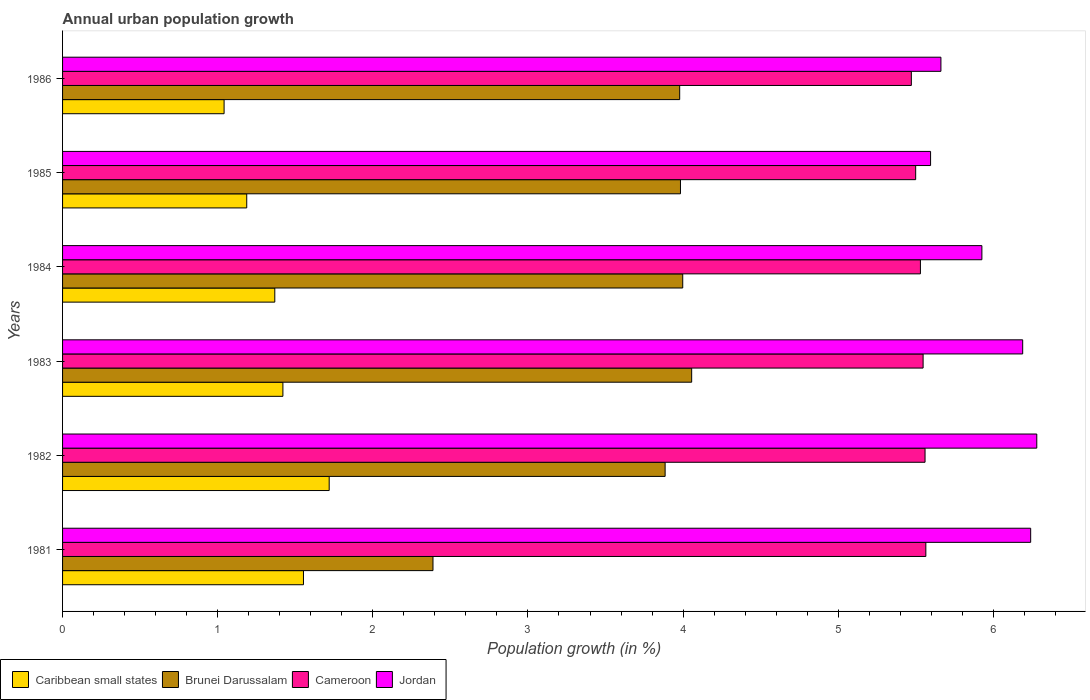How many different coloured bars are there?
Your answer should be very brief. 4. Are the number of bars per tick equal to the number of legend labels?
Your answer should be very brief. Yes. How many bars are there on the 1st tick from the top?
Your answer should be compact. 4. What is the label of the 4th group of bars from the top?
Make the answer very short. 1983. In how many cases, is the number of bars for a given year not equal to the number of legend labels?
Offer a very short reply. 0. What is the percentage of urban population growth in Jordan in 1983?
Ensure brevity in your answer.  6.19. Across all years, what is the maximum percentage of urban population growth in Jordan?
Make the answer very short. 6.28. Across all years, what is the minimum percentage of urban population growth in Brunei Darussalam?
Your answer should be compact. 2.39. In which year was the percentage of urban population growth in Jordan minimum?
Provide a succinct answer. 1985. What is the total percentage of urban population growth in Cameroon in the graph?
Ensure brevity in your answer.  33.17. What is the difference between the percentage of urban population growth in Jordan in 1983 and that in 1986?
Your answer should be compact. 0.53. What is the difference between the percentage of urban population growth in Cameroon in 1985 and the percentage of urban population growth in Jordan in 1986?
Provide a succinct answer. -0.16. What is the average percentage of urban population growth in Caribbean small states per year?
Offer a terse response. 1.38. In the year 1984, what is the difference between the percentage of urban population growth in Cameroon and percentage of urban population growth in Brunei Darussalam?
Your answer should be very brief. 1.53. What is the ratio of the percentage of urban population growth in Caribbean small states in 1982 to that in 1986?
Offer a very short reply. 1.65. Is the percentage of urban population growth in Cameroon in 1983 less than that in 1986?
Make the answer very short. No. What is the difference between the highest and the second highest percentage of urban population growth in Caribbean small states?
Keep it short and to the point. 0.17. What is the difference between the highest and the lowest percentage of urban population growth in Jordan?
Keep it short and to the point. 0.68. What does the 3rd bar from the top in 1984 represents?
Offer a very short reply. Brunei Darussalam. What does the 3rd bar from the bottom in 1981 represents?
Provide a succinct answer. Cameroon. How many bars are there?
Make the answer very short. 24. Are all the bars in the graph horizontal?
Offer a terse response. Yes. How many years are there in the graph?
Offer a very short reply. 6. What is the difference between two consecutive major ticks on the X-axis?
Keep it short and to the point. 1. Does the graph contain any zero values?
Give a very brief answer. No. What is the title of the graph?
Your answer should be compact. Annual urban population growth. What is the label or title of the X-axis?
Provide a short and direct response. Population growth (in %). What is the Population growth (in %) of Caribbean small states in 1981?
Your response must be concise. 1.55. What is the Population growth (in %) in Brunei Darussalam in 1981?
Your response must be concise. 2.39. What is the Population growth (in %) in Cameroon in 1981?
Provide a succinct answer. 5.56. What is the Population growth (in %) of Jordan in 1981?
Keep it short and to the point. 6.24. What is the Population growth (in %) of Caribbean small states in 1982?
Keep it short and to the point. 1.72. What is the Population growth (in %) of Brunei Darussalam in 1982?
Ensure brevity in your answer.  3.88. What is the Population growth (in %) of Cameroon in 1982?
Give a very brief answer. 5.56. What is the Population growth (in %) in Jordan in 1982?
Your answer should be compact. 6.28. What is the Population growth (in %) of Caribbean small states in 1983?
Ensure brevity in your answer.  1.42. What is the Population growth (in %) in Brunei Darussalam in 1983?
Ensure brevity in your answer.  4.06. What is the Population growth (in %) of Cameroon in 1983?
Make the answer very short. 5.55. What is the Population growth (in %) of Jordan in 1983?
Give a very brief answer. 6.19. What is the Population growth (in %) in Caribbean small states in 1984?
Offer a terse response. 1.37. What is the Population growth (in %) in Brunei Darussalam in 1984?
Ensure brevity in your answer.  4. What is the Population growth (in %) of Cameroon in 1984?
Provide a succinct answer. 5.53. What is the Population growth (in %) in Jordan in 1984?
Give a very brief answer. 5.93. What is the Population growth (in %) in Caribbean small states in 1985?
Offer a terse response. 1.19. What is the Population growth (in %) in Brunei Darussalam in 1985?
Keep it short and to the point. 3.98. What is the Population growth (in %) in Cameroon in 1985?
Offer a very short reply. 5.5. What is the Population growth (in %) in Jordan in 1985?
Offer a very short reply. 5.6. What is the Population growth (in %) in Caribbean small states in 1986?
Keep it short and to the point. 1.04. What is the Population growth (in %) in Brunei Darussalam in 1986?
Keep it short and to the point. 3.98. What is the Population growth (in %) in Cameroon in 1986?
Provide a short and direct response. 5.47. What is the Population growth (in %) of Jordan in 1986?
Provide a succinct answer. 5.66. Across all years, what is the maximum Population growth (in %) in Caribbean small states?
Your answer should be compact. 1.72. Across all years, what is the maximum Population growth (in %) in Brunei Darussalam?
Provide a short and direct response. 4.06. Across all years, what is the maximum Population growth (in %) in Cameroon?
Give a very brief answer. 5.56. Across all years, what is the maximum Population growth (in %) in Jordan?
Your answer should be compact. 6.28. Across all years, what is the minimum Population growth (in %) in Caribbean small states?
Your response must be concise. 1.04. Across all years, what is the minimum Population growth (in %) in Brunei Darussalam?
Make the answer very short. 2.39. Across all years, what is the minimum Population growth (in %) of Cameroon?
Ensure brevity in your answer.  5.47. Across all years, what is the minimum Population growth (in %) of Jordan?
Provide a short and direct response. 5.6. What is the total Population growth (in %) in Caribbean small states in the graph?
Keep it short and to the point. 8.29. What is the total Population growth (in %) in Brunei Darussalam in the graph?
Offer a terse response. 22.29. What is the total Population growth (in %) in Cameroon in the graph?
Offer a very short reply. 33.17. What is the total Population growth (in %) of Jordan in the graph?
Your response must be concise. 35.89. What is the difference between the Population growth (in %) in Caribbean small states in 1981 and that in 1982?
Keep it short and to the point. -0.17. What is the difference between the Population growth (in %) in Brunei Darussalam in 1981 and that in 1982?
Provide a short and direct response. -1.5. What is the difference between the Population growth (in %) of Cameroon in 1981 and that in 1982?
Provide a short and direct response. 0.01. What is the difference between the Population growth (in %) in Jordan in 1981 and that in 1982?
Keep it short and to the point. -0.04. What is the difference between the Population growth (in %) of Caribbean small states in 1981 and that in 1983?
Ensure brevity in your answer.  0.13. What is the difference between the Population growth (in %) of Brunei Darussalam in 1981 and that in 1983?
Keep it short and to the point. -1.67. What is the difference between the Population growth (in %) of Cameroon in 1981 and that in 1983?
Offer a terse response. 0.02. What is the difference between the Population growth (in %) in Jordan in 1981 and that in 1983?
Your answer should be compact. 0.05. What is the difference between the Population growth (in %) in Caribbean small states in 1981 and that in 1984?
Provide a succinct answer. 0.18. What is the difference between the Population growth (in %) of Brunei Darussalam in 1981 and that in 1984?
Provide a succinct answer. -1.61. What is the difference between the Population growth (in %) in Cameroon in 1981 and that in 1984?
Give a very brief answer. 0.03. What is the difference between the Population growth (in %) of Jordan in 1981 and that in 1984?
Keep it short and to the point. 0.31. What is the difference between the Population growth (in %) in Caribbean small states in 1981 and that in 1985?
Provide a short and direct response. 0.37. What is the difference between the Population growth (in %) in Brunei Darussalam in 1981 and that in 1985?
Your response must be concise. -1.6. What is the difference between the Population growth (in %) of Cameroon in 1981 and that in 1985?
Your answer should be compact. 0.07. What is the difference between the Population growth (in %) of Jordan in 1981 and that in 1985?
Ensure brevity in your answer.  0.65. What is the difference between the Population growth (in %) in Caribbean small states in 1981 and that in 1986?
Your answer should be very brief. 0.51. What is the difference between the Population growth (in %) in Brunei Darussalam in 1981 and that in 1986?
Make the answer very short. -1.59. What is the difference between the Population growth (in %) of Cameroon in 1981 and that in 1986?
Your answer should be very brief. 0.09. What is the difference between the Population growth (in %) of Jordan in 1981 and that in 1986?
Make the answer very short. 0.58. What is the difference between the Population growth (in %) in Caribbean small states in 1982 and that in 1983?
Ensure brevity in your answer.  0.3. What is the difference between the Population growth (in %) in Brunei Darussalam in 1982 and that in 1983?
Your answer should be very brief. -0.17. What is the difference between the Population growth (in %) of Cameroon in 1982 and that in 1983?
Offer a very short reply. 0.01. What is the difference between the Population growth (in %) in Jordan in 1982 and that in 1983?
Provide a succinct answer. 0.09. What is the difference between the Population growth (in %) of Caribbean small states in 1982 and that in 1984?
Your answer should be very brief. 0.35. What is the difference between the Population growth (in %) of Brunei Darussalam in 1982 and that in 1984?
Provide a succinct answer. -0.11. What is the difference between the Population growth (in %) of Cameroon in 1982 and that in 1984?
Your answer should be very brief. 0.03. What is the difference between the Population growth (in %) in Jordan in 1982 and that in 1984?
Provide a short and direct response. 0.35. What is the difference between the Population growth (in %) in Caribbean small states in 1982 and that in 1985?
Your answer should be very brief. 0.53. What is the difference between the Population growth (in %) of Brunei Darussalam in 1982 and that in 1985?
Make the answer very short. -0.1. What is the difference between the Population growth (in %) of Cameroon in 1982 and that in 1985?
Your response must be concise. 0.06. What is the difference between the Population growth (in %) of Jordan in 1982 and that in 1985?
Keep it short and to the point. 0.68. What is the difference between the Population growth (in %) of Caribbean small states in 1982 and that in 1986?
Keep it short and to the point. 0.68. What is the difference between the Population growth (in %) in Brunei Darussalam in 1982 and that in 1986?
Offer a terse response. -0.09. What is the difference between the Population growth (in %) in Cameroon in 1982 and that in 1986?
Your response must be concise. 0.09. What is the difference between the Population growth (in %) of Jordan in 1982 and that in 1986?
Your response must be concise. 0.62. What is the difference between the Population growth (in %) of Caribbean small states in 1983 and that in 1984?
Provide a succinct answer. 0.05. What is the difference between the Population growth (in %) in Brunei Darussalam in 1983 and that in 1984?
Offer a terse response. 0.06. What is the difference between the Population growth (in %) in Cameroon in 1983 and that in 1984?
Provide a short and direct response. 0.02. What is the difference between the Population growth (in %) of Jordan in 1983 and that in 1984?
Your answer should be very brief. 0.26. What is the difference between the Population growth (in %) in Caribbean small states in 1983 and that in 1985?
Provide a succinct answer. 0.23. What is the difference between the Population growth (in %) of Brunei Darussalam in 1983 and that in 1985?
Make the answer very short. 0.07. What is the difference between the Population growth (in %) of Cameroon in 1983 and that in 1985?
Your answer should be compact. 0.05. What is the difference between the Population growth (in %) in Jordan in 1983 and that in 1985?
Ensure brevity in your answer.  0.59. What is the difference between the Population growth (in %) in Caribbean small states in 1983 and that in 1986?
Offer a very short reply. 0.38. What is the difference between the Population growth (in %) in Brunei Darussalam in 1983 and that in 1986?
Your answer should be compact. 0.08. What is the difference between the Population growth (in %) in Cameroon in 1983 and that in 1986?
Provide a succinct answer. 0.08. What is the difference between the Population growth (in %) of Jordan in 1983 and that in 1986?
Offer a very short reply. 0.53. What is the difference between the Population growth (in %) in Caribbean small states in 1984 and that in 1985?
Offer a very short reply. 0.18. What is the difference between the Population growth (in %) in Brunei Darussalam in 1984 and that in 1985?
Provide a short and direct response. 0.01. What is the difference between the Population growth (in %) of Cameroon in 1984 and that in 1985?
Your answer should be compact. 0.03. What is the difference between the Population growth (in %) in Jordan in 1984 and that in 1985?
Provide a succinct answer. 0.33. What is the difference between the Population growth (in %) in Caribbean small states in 1984 and that in 1986?
Make the answer very short. 0.33. What is the difference between the Population growth (in %) of Brunei Darussalam in 1984 and that in 1986?
Your answer should be compact. 0.02. What is the difference between the Population growth (in %) in Cameroon in 1984 and that in 1986?
Give a very brief answer. 0.06. What is the difference between the Population growth (in %) of Jordan in 1984 and that in 1986?
Provide a short and direct response. 0.26. What is the difference between the Population growth (in %) in Caribbean small states in 1985 and that in 1986?
Your answer should be compact. 0.15. What is the difference between the Population growth (in %) in Brunei Darussalam in 1985 and that in 1986?
Your response must be concise. 0.01. What is the difference between the Population growth (in %) of Cameroon in 1985 and that in 1986?
Make the answer very short. 0.03. What is the difference between the Population growth (in %) of Jordan in 1985 and that in 1986?
Provide a succinct answer. -0.07. What is the difference between the Population growth (in %) of Caribbean small states in 1981 and the Population growth (in %) of Brunei Darussalam in 1982?
Provide a succinct answer. -2.33. What is the difference between the Population growth (in %) of Caribbean small states in 1981 and the Population growth (in %) of Cameroon in 1982?
Make the answer very short. -4.01. What is the difference between the Population growth (in %) in Caribbean small states in 1981 and the Population growth (in %) in Jordan in 1982?
Keep it short and to the point. -4.73. What is the difference between the Population growth (in %) in Brunei Darussalam in 1981 and the Population growth (in %) in Cameroon in 1982?
Make the answer very short. -3.17. What is the difference between the Population growth (in %) in Brunei Darussalam in 1981 and the Population growth (in %) in Jordan in 1982?
Ensure brevity in your answer.  -3.89. What is the difference between the Population growth (in %) of Cameroon in 1981 and the Population growth (in %) of Jordan in 1982?
Offer a terse response. -0.72. What is the difference between the Population growth (in %) of Caribbean small states in 1981 and the Population growth (in %) of Brunei Darussalam in 1983?
Offer a terse response. -2.5. What is the difference between the Population growth (in %) of Caribbean small states in 1981 and the Population growth (in %) of Cameroon in 1983?
Your answer should be compact. -3.99. What is the difference between the Population growth (in %) in Caribbean small states in 1981 and the Population growth (in %) in Jordan in 1983?
Ensure brevity in your answer.  -4.64. What is the difference between the Population growth (in %) of Brunei Darussalam in 1981 and the Population growth (in %) of Cameroon in 1983?
Your response must be concise. -3.16. What is the difference between the Population growth (in %) of Brunei Darussalam in 1981 and the Population growth (in %) of Jordan in 1983?
Your answer should be compact. -3.8. What is the difference between the Population growth (in %) in Cameroon in 1981 and the Population growth (in %) in Jordan in 1983?
Make the answer very short. -0.62. What is the difference between the Population growth (in %) in Caribbean small states in 1981 and the Population growth (in %) in Brunei Darussalam in 1984?
Offer a terse response. -2.44. What is the difference between the Population growth (in %) in Caribbean small states in 1981 and the Population growth (in %) in Cameroon in 1984?
Give a very brief answer. -3.98. What is the difference between the Population growth (in %) in Caribbean small states in 1981 and the Population growth (in %) in Jordan in 1984?
Offer a very short reply. -4.37. What is the difference between the Population growth (in %) of Brunei Darussalam in 1981 and the Population growth (in %) of Cameroon in 1984?
Offer a very short reply. -3.14. What is the difference between the Population growth (in %) in Brunei Darussalam in 1981 and the Population growth (in %) in Jordan in 1984?
Keep it short and to the point. -3.54. What is the difference between the Population growth (in %) of Cameroon in 1981 and the Population growth (in %) of Jordan in 1984?
Give a very brief answer. -0.36. What is the difference between the Population growth (in %) in Caribbean small states in 1981 and the Population growth (in %) in Brunei Darussalam in 1985?
Provide a short and direct response. -2.43. What is the difference between the Population growth (in %) in Caribbean small states in 1981 and the Population growth (in %) in Cameroon in 1985?
Your answer should be compact. -3.95. What is the difference between the Population growth (in %) in Caribbean small states in 1981 and the Population growth (in %) in Jordan in 1985?
Your answer should be compact. -4.04. What is the difference between the Population growth (in %) in Brunei Darussalam in 1981 and the Population growth (in %) in Cameroon in 1985?
Ensure brevity in your answer.  -3.11. What is the difference between the Population growth (in %) of Brunei Darussalam in 1981 and the Population growth (in %) of Jordan in 1985?
Offer a terse response. -3.21. What is the difference between the Population growth (in %) of Cameroon in 1981 and the Population growth (in %) of Jordan in 1985?
Make the answer very short. -0.03. What is the difference between the Population growth (in %) of Caribbean small states in 1981 and the Population growth (in %) of Brunei Darussalam in 1986?
Your response must be concise. -2.43. What is the difference between the Population growth (in %) in Caribbean small states in 1981 and the Population growth (in %) in Cameroon in 1986?
Offer a very short reply. -3.92. What is the difference between the Population growth (in %) in Caribbean small states in 1981 and the Population growth (in %) in Jordan in 1986?
Your answer should be compact. -4.11. What is the difference between the Population growth (in %) of Brunei Darussalam in 1981 and the Population growth (in %) of Cameroon in 1986?
Give a very brief answer. -3.08. What is the difference between the Population growth (in %) of Brunei Darussalam in 1981 and the Population growth (in %) of Jordan in 1986?
Give a very brief answer. -3.27. What is the difference between the Population growth (in %) of Cameroon in 1981 and the Population growth (in %) of Jordan in 1986?
Your answer should be very brief. -0.1. What is the difference between the Population growth (in %) of Caribbean small states in 1982 and the Population growth (in %) of Brunei Darussalam in 1983?
Offer a terse response. -2.34. What is the difference between the Population growth (in %) of Caribbean small states in 1982 and the Population growth (in %) of Cameroon in 1983?
Ensure brevity in your answer.  -3.83. What is the difference between the Population growth (in %) of Caribbean small states in 1982 and the Population growth (in %) of Jordan in 1983?
Your response must be concise. -4.47. What is the difference between the Population growth (in %) of Brunei Darussalam in 1982 and the Population growth (in %) of Cameroon in 1983?
Offer a terse response. -1.66. What is the difference between the Population growth (in %) of Brunei Darussalam in 1982 and the Population growth (in %) of Jordan in 1983?
Offer a terse response. -2.31. What is the difference between the Population growth (in %) of Cameroon in 1982 and the Population growth (in %) of Jordan in 1983?
Offer a terse response. -0.63. What is the difference between the Population growth (in %) of Caribbean small states in 1982 and the Population growth (in %) of Brunei Darussalam in 1984?
Your answer should be very brief. -2.28. What is the difference between the Population growth (in %) of Caribbean small states in 1982 and the Population growth (in %) of Cameroon in 1984?
Ensure brevity in your answer.  -3.81. What is the difference between the Population growth (in %) of Caribbean small states in 1982 and the Population growth (in %) of Jordan in 1984?
Offer a very short reply. -4.21. What is the difference between the Population growth (in %) of Brunei Darussalam in 1982 and the Population growth (in %) of Cameroon in 1984?
Provide a succinct answer. -1.65. What is the difference between the Population growth (in %) of Brunei Darussalam in 1982 and the Population growth (in %) of Jordan in 1984?
Provide a succinct answer. -2.04. What is the difference between the Population growth (in %) in Cameroon in 1982 and the Population growth (in %) in Jordan in 1984?
Your response must be concise. -0.37. What is the difference between the Population growth (in %) in Caribbean small states in 1982 and the Population growth (in %) in Brunei Darussalam in 1985?
Your answer should be very brief. -2.26. What is the difference between the Population growth (in %) in Caribbean small states in 1982 and the Population growth (in %) in Cameroon in 1985?
Offer a terse response. -3.78. What is the difference between the Population growth (in %) in Caribbean small states in 1982 and the Population growth (in %) in Jordan in 1985?
Offer a very short reply. -3.88. What is the difference between the Population growth (in %) of Brunei Darussalam in 1982 and the Population growth (in %) of Cameroon in 1985?
Your response must be concise. -1.62. What is the difference between the Population growth (in %) in Brunei Darussalam in 1982 and the Population growth (in %) in Jordan in 1985?
Make the answer very short. -1.71. What is the difference between the Population growth (in %) of Cameroon in 1982 and the Population growth (in %) of Jordan in 1985?
Offer a terse response. -0.04. What is the difference between the Population growth (in %) in Caribbean small states in 1982 and the Population growth (in %) in Brunei Darussalam in 1986?
Make the answer very short. -2.26. What is the difference between the Population growth (in %) of Caribbean small states in 1982 and the Population growth (in %) of Cameroon in 1986?
Ensure brevity in your answer.  -3.75. What is the difference between the Population growth (in %) of Caribbean small states in 1982 and the Population growth (in %) of Jordan in 1986?
Offer a very short reply. -3.94. What is the difference between the Population growth (in %) of Brunei Darussalam in 1982 and the Population growth (in %) of Cameroon in 1986?
Provide a short and direct response. -1.59. What is the difference between the Population growth (in %) in Brunei Darussalam in 1982 and the Population growth (in %) in Jordan in 1986?
Give a very brief answer. -1.78. What is the difference between the Population growth (in %) of Cameroon in 1982 and the Population growth (in %) of Jordan in 1986?
Keep it short and to the point. -0.1. What is the difference between the Population growth (in %) in Caribbean small states in 1983 and the Population growth (in %) in Brunei Darussalam in 1984?
Your response must be concise. -2.58. What is the difference between the Population growth (in %) in Caribbean small states in 1983 and the Population growth (in %) in Cameroon in 1984?
Ensure brevity in your answer.  -4.11. What is the difference between the Population growth (in %) in Caribbean small states in 1983 and the Population growth (in %) in Jordan in 1984?
Make the answer very short. -4.51. What is the difference between the Population growth (in %) of Brunei Darussalam in 1983 and the Population growth (in %) of Cameroon in 1984?
Your answer should be very brief. -1.47. What is the difference between the Population growth (in %) in Brunei Darussalam in 1983 and the Population growth (in %) in Jordan in 1984?
Ensure brevity in your answer.  -1.87. What is the difference between the Population growth (in %) in Cameroon in 1983 and the Population growth (in %) in Jordan in 1984?
Keep it short and to the point. -0.38. What is the difference between the Population growth (in %) in Caribbean small states in 1983 and the Population growth (in %) in Brunei Darussalam in 1985?
Your answer should be very brief. -2.56. What is the difference between the Population growth (in %) in Caribbean small states in 1983 and the Population growth (in %) in Cameroon in 1985?
Make the answer very short. -4.08. What is the difference between the Population growth (in %) in Caribbean small states in 1983 and the Population growth (in %) in Jordan in 1985?
Ensure brevity in your answer.  -4.17. What is the difference between the Population growth (in %) of Brunei Darussalam in 1983 and the Population growth (in %) of Cameroon in 1985?
Your response must be concise. -1.44. What is the difference between the Population growth (in %) in Brunei Darussalam in 1983 and the Population growth (in %) in Jordan in 1985?
Your answer should be compact. -1.54. What is the difference between the Population growth (in %) of Cameroon in 1983 and the Population growth (in %) of Jordan in 1985?
Make the answer very short. -0.05. What is the difference between the Population growth (in %) of Caribbean small states in 1983 and the Population growth (in %) of Brunei Darussalam in 1986?
Keep it short and to the point. -2.56. What is the difference between the Population growth (in %) of Caribbean small states in 1983 and the Population growth (in %) of Cameroon in 1986?
Provide a succinct answer. -4.05. What is the difference between the Population growth (in %) in Caribbean small states in 1983 and the Population growth (in %) in Jordan in 1986?
Your answer should be very brief. -4.24. What is the difference between the Population growth (in %) of Brunei Darussalam in 1983 and the Population growth (in %) of Cameroon in 1986?
Give a very brief answer. -1.42. What is the difference between the Population growth (in %) in Brunei Darussalam in 1983 and the Population growth (in %) in Jordan in 1986?
Ensure brevity in your answer.  -1.61. What is the difference between the Population growth (in %) in Cameroon in 1983 and the Population growth (in %) in Jordan in 1986?
Offer a very short reply. -0.11. What is the difference between the Population growth (in %) in Caribbean small states in 1984 and the Population growth (in %) in Brunei Darussalam in 1985?
Your response must be concise. -2.62. What is the difference between the Population growth (in %) in Caribbean small states in 1984 and the Population growth (in %) in Cameroon in 1985?
Provide a short and direct response. -4.13. What is the difference between the Population growth (in %) of Caribbean small states in 1984 and the Population growth (in %) of Jordan in 1985?
Offer a very short reply. -4.23. What is the difference between the Population growth (in %) in Brunei Darussalam in 1984 and the Population growth (in %) in Cameroon in 1985?
Make the answer very short. -1.5. What is the difference between the Population growth (in %) of Brunei Darussalam in 1984 and the Population growth (in %) of Jordan in 1985?
Offer a very short reply. -1.6. What is the difference between the Population growth (in %) of Cameroon in 1984 and the Population growth (in %) of Jordan in 1985?
Provide a short and direct response. -0.07. What is the difference between the Population growth (in %) in Caribbean small states in 1984 and the Population growth (in %) in Brunei Darussalam in 1986?
Give a very brief answer. -2.61. What is the difference between the Population growth (in %) in Caribbean small states in 1984 and the Population growth (in %) in Cameroon in 1986?
Your response must be concise. -4.1. What is the difference between the Population growth (in %) of Caribbean small states in 1984 and the Population growth (in %) of Jordan in 1986?
Offer a terse response. -4.29. What is the difference between the Population growth (in %) of Brunei Darussalam in 1984 and the Population growth (in %) of Cameroon in 1986?
Make the answer very short. -1.47. What is the difference between the Population growth (in %) in Brunei Darussalam in 1984 and the Population growth (in %) in Jordan in 1986?
Provide a succinct answer. -1.66. What is the difference between the Population growth (in %) in Cameroon in 1984 and the Population growth (in %) in Jordan in 1986?
Offer a terse response. -0.13. What is the difference between the Population growth (in %) of Caribbean small states in 1985 and the Population growth (in %) of Brunei Darussalam in 1986?
Give a very brief answer. -2.79. What is the difference between the Population growth (in %) in Caribbean small states in 1985 and the Population growth (in %) in Cameroon in 1986?
Keep it short and to the point. -4.28. What is the difference between the Population growth (in %) in Caribbean small states in 1985 and the Population growth (in %) in Jordan in 1986?
Make the answer very short. -4.47. What is the difference between the Population growth (in %) of Brunei Darussalam in 1985 and the Population growth (in %) of Cameroon in 1986?
Ensure brevity in your answer.  -1.49. What is the difference between the Population growth (in %) of Brunei Darussalam in 1985 and the Population growth (in %) of Jordan in 1986?
Make the answer very short. -1.68. What is the difference between the Population growth (in %) of Cameroon in 1985 and the Population growth (in %) of Jordan in 1986?
Provide a short and direct response. -0.16. What is the average Population growth (in %) of Caribbean small states per year?
Your response must be concise. 1.38. What is the average Population growth (in %) in Brunei Darussalam per year?
Your answer should be very brief. 3.71. What is the average Population growth (in %) in Cameroon per year?
Make the answer very short. 5.53. What is the average Population growth (in %) in Jordan per year?
Your answer should be very brief. 5.98. In the year 1981, what is the difference between the Population growth (in %) of Caribbean small states and Population growth (in %) of Brunei Darussalam?
Your answer should be very brief. -0.83. In the year 1981, what is the difference between the Population growth (in %) of Caribbean small states and Population growth (in %) of Cameroon?
Ensure brevity in your answer.  -4.01. In the year 1981, what is the difference between the Population growth (in %) in Caribbean small states and Population growth (in %) in Jordan?
Make the answer very short. -4.69. In the year 1981, what is the difference between the Population growth (in %) of Brunei Darussalam and Population growth (in %) of Cameroon?
Provide a short and direct response. -3.18. In the year 1981, what is the difference between the Population growth (in %) of Brunei Darussalam and Population growth (in %) of Jordan?
Provide a short and direct response. -3.85. In the year 1981, what is the difference between the Population growth (in %) in Cameroon and Population growth (in %) in Jordan?
Keep it short and to the point. -0.68. In the year 1982, what is the difference between the Population growth (in %) in Caribbean small states and Population growth (in %) in Brunei Darussalam?
Your response must be concise. -2.17. In the year 1982, what is the difference between the Population growth (in %) of Caribbean small states and Population growth (in %) of Cameroon?
Your answer should be compact. -3.84. In the year 1982, what is the difference between the Population growth (in %) of Caribbean small states and Population growth (in %) of Jordan?
Keep it short and to the point. -4.56. In the year 1982, what is the difference between the Population growth (in %) of Brunei Darussalam and Population growth (in %) of Cameroon?
Make the answer very short. -1.68. In the year 1982, what is the difference between the Population growth (in %) of Brunei Darussalam and Population growth (in %) of Jordan?
Your answer should be very brief. -2.4. In the year 1982, what is the difference between the Population growth (in %) of Cameroon and Population growth (in %) of Jordan?
Provide a succinct answer. -0.72. In the year 1983, what is the difference between the Population growth (in %) in Caribbean small states and Population growth (in %) in Brunei Darussalam?
Provide a succinct answer. -2.63. In the year 1983, what is the difference between the Population growth (in %) of Caribbean small states and Population growth (in %) of Cameroon?
Your answer should be very brief. -4.13. In the year 1983, what is the difference between the Population growth (in %) of Caribbean small states and Population growth (in %) of Jordan?
Give a very brief answer. -4.77. In the year 1983, what is the difference between the Population growth (in %) in Brunei Darussalam and Population growth (in %) in Cameroon?
Your answer should be compact. -1.49. In the year 1983, what is the difference between the Population growth (in %) in Brunei Darussalam and Population growth (in %) in Jordan?
Give a very brief answer. -2.13. In the year 1983, what is the difference between the Population growth (in %) of Cameroon and Population growth (in %) of Jordan?
Keep it short and to the point. -0.64. In the year 1984, what is the difference between the Population growth (in %) in Caribbean small states and Population growth (in %) in Brunei Darussalam?
Offer a terse response. -2.63. In the year 1984, what is the difference between the Population growth (in %) in Caribbean small states and Population growth (in %) in Cameroon?
Keep it short and to the point. -4.16. In the year 1984, what is the difference between the Population growth (in %) in Caribbean small states and Population growth (in %) in Jordan?
Your response must be concise. -4.56. In the year 1984, what is the difference between the Population growth (in %) of Brunei Darussalam and Population growth (in %) of Cameroon?
Your answer should be compact. -1.53. In the year 1984, what is the difference between the Population growth (in %) of Brunei Darussalam and Population growth (in %) of Jordan?
Keep it short and to the point. -1.93. In the year 1984, what is the difference between the Population growth (in %) in Cameroon and Population growth (in %) in Jordan?
Your answer should be very brief. -0.4. In the year 1985, what is the difference between the Population growth (in %) of Caribbean small states and Population growth (in %) of Brunei Darussalam?
Provide a succinct answer. -2.8. In the year 1985, what is the difference between the Population growth (in %) of Caribbean small states and Population growth (in %) of Cameroon?
Offer a very short reply. -4.31. In the year 1985, what is the difference between the Population growth (in %) in Caribbean small states and Population growth (in %) in Jordan?
Make the answer very short. -4.41. In the year 1985, what is the difference between the Population growth (in %) of Brunei Darussalam and Population growth (in %) of Cameroon?
Provide a short and direct response. -1.52. In the year 1985, what is the difference between the Population growth (in %) in Brunei Darussalam and Population growth (in %) in Jordan?
Provide a short and direct response. -1.61. In the year 1985, what is the difference between the Population growth (in %) of Cameroon and Population growth (in %) of Jordan?
Offer a terse response. -0.1. In the year 1986, what is the difference between the Population growth (in %) of Caribbean small states and Population growth (in %) of Brunei Darussalam?
Keep it short and to the point. -2.94. In the year 1986, what is the difference between the Population growth (in %) of Caribbean small states and Population growth (in %) of Cameroon?
Your answer should be compact. -4.43. In the year 1986, what is the difference between the Population growth (in %) of Caribbean small states and Population growth (in %) of Jordan?
Your answer should be compact. -4.62. In the year 1986, what is the difference between the Population growth (in %) of Brunei Darussalam and Population growth (in %) of Cameroon?
Offer a terse response. -1.49. In the year 1986, what is the difference between the Population growth (in %) of Brunei Darussalam and Population growth (in %) of Jordan?
Make the answer very short. -1.68. In the year 1986, what is the difference between the Population growth (in %) in Cameroon and Population growth (in %) in Jordan?
Ensure brevity in your answer.  -0.19. What is the ratio of the Population growth (in %) of Caribbean small states in 1981 to that in 1982?
Offer a very short reply. 0.9. What is the ratio of the Population growth (in %) in Brunei Darussalam in 1981 to that in 1982?
Provide a short and direct response. 0.61. What is the ratio of the Population growth (in %) in Caribbean small states in 1981 to that in 1983?
Your answer should be compact. 1.09. What is the ratio of the Population growth (in %) of Brunei Darussalam in 1981 to that in 1983?
Offer a very short reply. 0.59. What is the ratio of the Population growth (in %) in Cameroon in 1981 to that in 1983?
Provide a succinct answer. 1. What is the ratio of the Population growth (in %) of Jordan in 1981 to that in 1983?
Keep it short and to the point. 1.01. What is the ratio of the Population growth (in %) in Caribbean small states in 1981 to that in 1984?
Provide a succinct answer. 1.14. What is the ratio of the Population growth (in %) of Brunei Darussalam in 1981 to that in 1984?
Your answer should be compact. 0.6. What is the ratio of the Population growth (in %) in Jordan in 1981 to that in 1984?
Your answer should be compact. 1.05. What is the ratio of the Population growth (in %) of Caribbean small states in 1981 to that in 1985?
Give a very brief answer. 1.31. What is the ratio of the Population growth (in %) of Brunei Darussalam in 1981 to that in 1985?
Make the answer very short. 0.6. What is the ratio of the Population growth (in %) in Cameroon in 1981 to that in 1985?
Your answer should be compact. 1.01. What is the ratio of the Population growth (in %) in Jordan in 1981 to that in 1985?
Keep it short and to the point. 1.12. What is the ratio of the Population growth (in %) of Caribbean small states in 1981 to that in 1986?
Provide a succinct answer. 1.49. What is the ratio of the Population growth (in %) of Brunei Darussalam in 1981 to that in 1986?
Make the answer very short. 0.6. What is the ratio of the Population growth (in %) in Cameroon in 1981 to that in 1986?
Keep it short and to the point. 1.02. What is the ratio of the Population growth (in %) of Jordan in 1981 to that in 1986?
Your answer should be very brief. 1.1. What is the ratio of the Population growth (in %) of Caribbean small states in 1982 to that in 1983?
Offer a very short reply. 1.21. What is the ratio of the Population growth (in %) of Brunei Darussalam in 1982 to that in 1983?
Offer a very short reply. 0.96. What is the ratio of the Population growth (in %) in Jordan in 1982 to that in 1983?
Make the answer very short. 1.01. What is the ratio of the Population growth (in %) in Caribbean small states in 1982 to that in 1984?
Offer a very short reply. 1.26. What is the ratio of the Population growth (in %) in Brunei Darussalam in 1982 to that in 1984?
Provide a succinct answer. 0.97. What is the ratio of the Population growth (in %) in Cameroon in 1982 to that in 1984?
Give a very brief answer. 1.01. What is the ratio of the Population growth (in %) in Jordan in 1982 to that in 1984?
Provide a succinct answer. 1.06. What is the ratio of the Population growth (in %) in Caribbean small states in 1982 to that in 1985?
Ensure brevity in your answer.  1.45. What is the ratio of the Population growth (in %) in Brunei Darussalam in 1982 to that in 1985?
Give a very brief answer. 0.98. What is the ratio of the Population growth (in %) of Jordan in 1982 to that in 1985?
Offer a terse response. 1.12. What is the ratio of the Population growth (in %) of Caribbean small states in 1982 to that in 1986?
Keep it short and to the point. 1.65. What is the ratio of the Population growth (in %) of Brunei Darussalam in 1982 to that in 1986?
Ensure brevity in your answer.  0.98. What is the ratio of the Population growth (in %) of Cameroon in 1982 to that in 1986?
Your answer should be compact. 1.02. What is the ratio of the Population growth (in %) in Jordan in 1982 to that in 1986?
Provide a succinct answer. 1.11. What is the ratio of the Population growth (in %) of Caribbean small states in 1983 to that in 1984?
Provide a short and direct response. 1.04. What is the ratio of the Population growth (in %) in Brunei Darussalam in 1983 to that in 1984?
Your response must be concise. 1.01. What is the ratio of the Population growth (in %) of Jordan in 1983 to that in 1984?
Offer a terse response. 1.04. What is the ratio of the Population growth (in %) of Caribbean small states in 1983 to that in 1985?
Provide a short and direct response. 1.2. What is the ratio of the Population growth (in %) of Brunei Darussalam in 1983 to that in 1985?
Provide a short and direct response. 1.02. What is the ratio of the Population growth (in %) in Cameroon in 1983 to that in 1985?
Your response must be concise. 1.01. What is the ratio of the Population growth (in %) of Jordan in 1983 to that in 1985?
Your answer should be very brief. 1.11. What is the ratio of the Population growth (in %) in Caribbean small states in 1983 to that in 1986?
Provide a short and direct response. 1.36. What is the ratio of the Population growth (in %) of Brunei Darussalam in 1983 to that in 1986?
Provide a succinct answer. 1.02. What is the ratio of the Population growth (in %) of Cameroon in 1983 to that in 1986?
Keep it short and to the point. 1.01. What is the ratio of the Population growth (in %) of Jordan in 1983 to that in 1986?
Your answer should be very brief. 1.09. What is the ratio of the Population growth (in %) of Caribbean small states in 1984 to that in 1985?
Give a very brief answer. 1.15. What is the ratio of the Population growth (in %) of Cameroon in 1984 to that in 1985?
Keep it short and to the point. 1.01. What is the ratio of the Population growth (in %) of Jordan in 1984 to that in 1985?
Your response must be concise. 1.06. What is the ratio of the Population growth (in %) of Caribbean small states in 1984 to that in 1986?
Make the answer very short. 1.31. What is the ratio of the Population growth (in %) of Cameroon in 1984 to that in 1986?
Your answer should be very brief. 1.01. What is the ratio of the Population growth (in %) of Jordan in 1984 to that in 1986?
Offer a very short reply. 1.05. What is the ratio of the Population growth (in %) in Caribbean small states in 1985 to that in 1986?
Your response must be concise. 1.14. What is the ratio of the Population growth (in %) in Brunei Darussalam in 1985 to that in 1986?
Your answer should be very brief. 1. What is the ratio of the Population growth (in %) of Jordan in 1985 to that in 1986?
Provide a short and direct response. 0.99. What is the difference between the highest and the second highest Population growth (in %) of Caribbean small states?
Make the answer very short. 0.17. What is the difference between the highest and the second highest Population growth (in %) of Brunei Darussalam?
Ensure brevity in your answer.  0.06. What is the difference between the highest and the second highest Population growth (in %) in Cameroon?
Offer a terse response. 0.01. What is the difference between the highest and the second highest Population growth (in %) of Jordan?
Provide a short and direct response. 0.04. What is the difference between the highest and the lowest Population growth (in %) of Caribbean small states?
Give a very brief answer. 0.68. What is the difference between the highest and the lowest Population growth (in %) in Brunei Darussalam?
Provide a succinct answer. 1.67. What is the difference between the highest and the lowest Population growth (in %) of Cameroon?
Your answer should be compact. 0.09. What is the difference between the highest and the lowest Population growth (in %) in Jordan?
Your response must be concise. 0.68. 